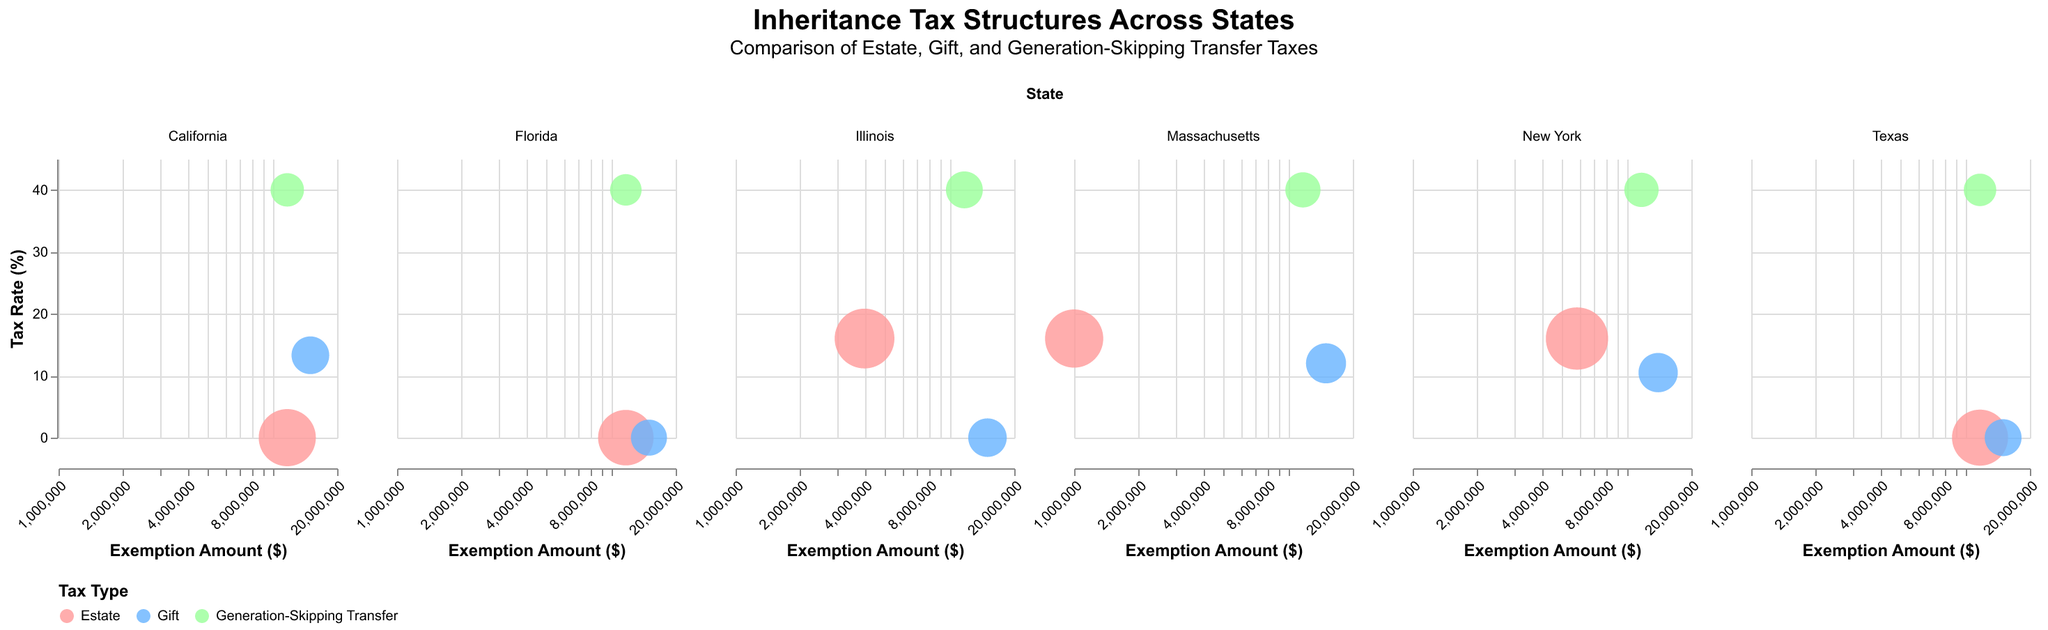What's the tax rate for estates in New York? Look at the bubble for New York corresponding to the "Estate" tax type. The y-axis shows the tax rate, which is 16% for New York estates.
Answer: 16% Which state has the highest estate tax exemption amount? Look at the bubbles corresponding to the "Estate" tax type across all states and compare their x-axis values. California, Texas, and Florida have the highest estate tax exemption amount of $11,700,000.
Answer: California, Texas, Florida How does the tax rate for gifts in California compare to New York? Locate the "Gift" tax type bubbles for both California and New York. For California, the y-axis shows 13.3%, and for New York, it shows 10.5%. California's rate is higher.
Answer: California's rate is higher What's the relationship between estate tax exemption amounts and gift tax exemption amounts across states? Examine the x-axis positions for "Estate" and "Gift" tax types across different states. Generally, gift tax exemptions (mostly $15,000,000) are higher than estate tax exemptions.
Answer: Gift tax exemptions are generally higher Which tax type has the largest bubble in Illinois? Identify which bubble in Illinois has the largest size. The estate tax bubble is the largest.
Answer: Estate tax Which state has the lowest exemption amount for estate taxes? Compare the x-axis values of "Estate" tax type bubbles across all states. Massachusetts has the lowest exemption amount of $1,000,000.
Answer: Massachusetts Compare the generation-skipping transfer tax rates across states. Which state has a different rate? Observe the y-axis values of generation-skipping transfer tax bubbles across all states. California, Texas, New York, Florida, Illinois, and Massachusetts all have the same rate of 40%. No state has a different rate.
Answer: No state What is the approximate size of the smallest bubble in the chart? Identify the smallest bubble visually and note its relative size compared to others. The smallest bubbles are the generation-skipping transfer tax bubbles for Florida with a size of approximately 130.
Answer: 130 